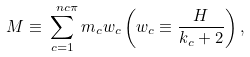<formula> <loc_0><loc_0><loc_500><loc_500>M \equiv \sum _ { c = 1 } ^ { \ n c \pi } m _ { c } w _ { c } \left ( w _ { c } \equiv \frac { H } { k _ { c } + 2 } \right ) ,</formula> 